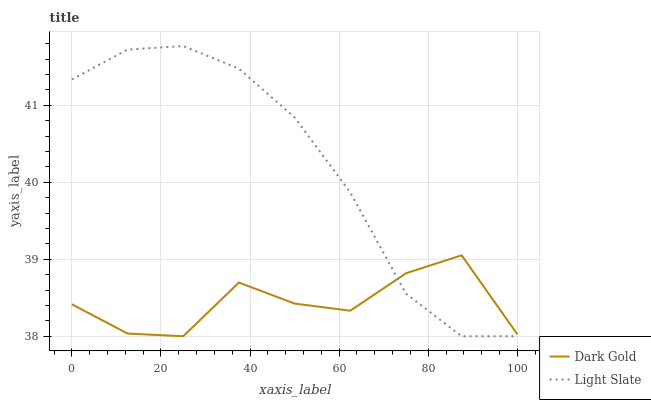Does Dark Gold have the minimum area under the curve?
Answer yes or no. Yes. Does Light Slate have the maximum area under the curve?
Answer yes or no. Yes. Does Dark Gold have the maximum area under the curve?
Answer yes or no. No. Is Light Slate the smoothest?
Answer yes or no. Yes. Is Dark Gold the roughest?
Answer yes or no. Yes. Is Dark Gold the smoothest?
Answer yes or no. No. Does Light Slate have the highest value?
Answer yes or no. Yes. Does Dark Gold have the highest value?
Answer yes or no. No. 